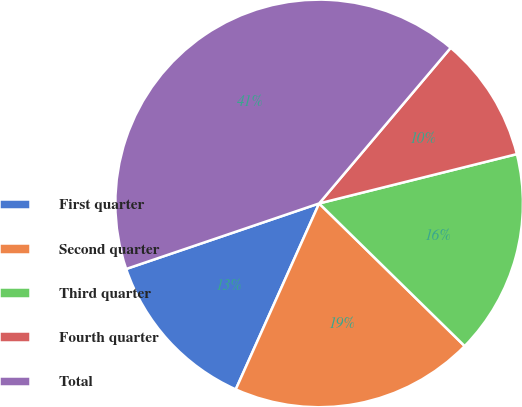Convert chart to OTSL. <chart><loc_0><loc_0><loc_500><loc_500><pie_chart><fcel>First quarter<fcel>Second quarter<fcel>Third quarter<fcel>Fourth quarter<fcel>Total<nl><fcel>13.08%<fcel>19.37%<fcel>16.23%<fcel>9.94%<fcel>41.38%<nl></chart> 